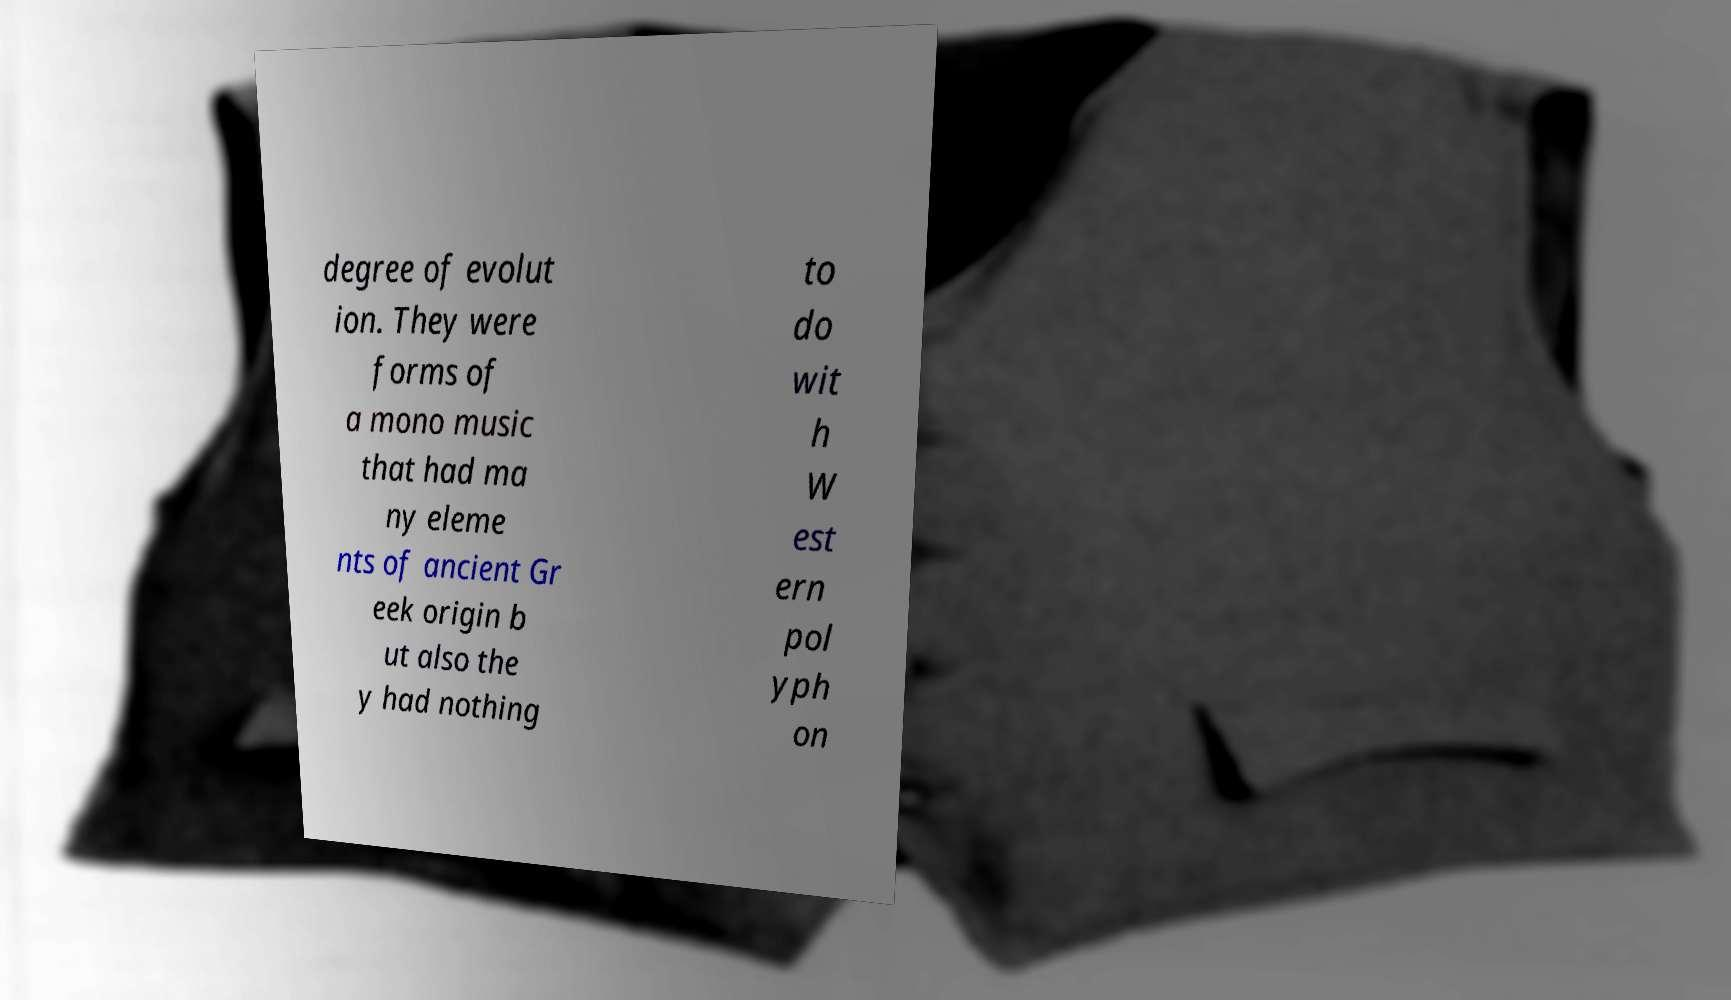For documentation purposes, I need the text within this image transcribed. Could you provide that? degree of evolut ion. They were forms of a mono music that had ma ny eleme nts of ancient Gr eek origin b ut also the y had nothing to do wit h W est ern pol yph on 